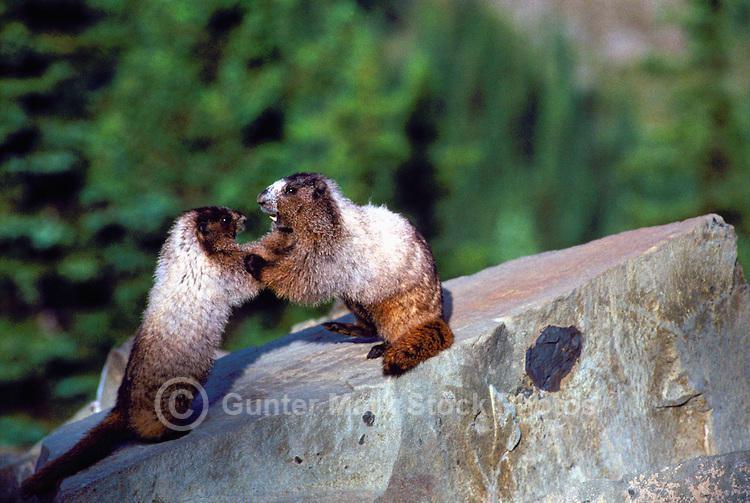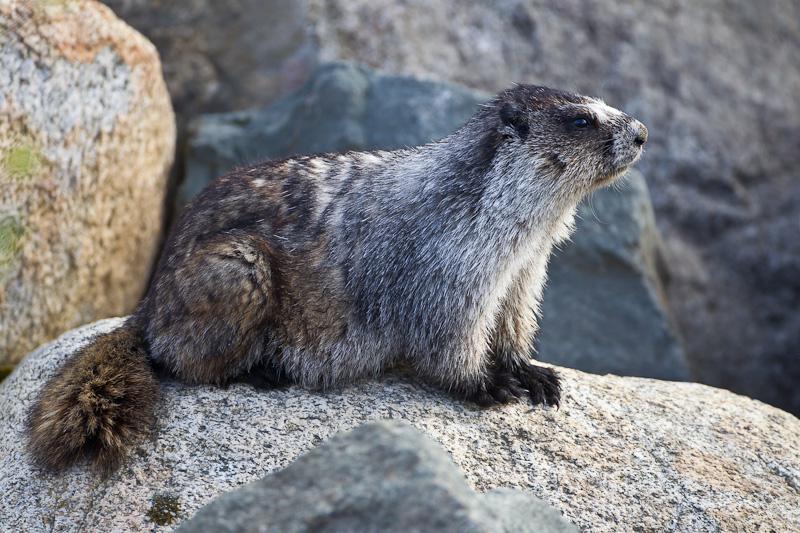The first image is the image on the left, the second image is the image on the right. For the images displayed, is the sentence "There is signal tan and brown animal sitting on a rock looking left." factually correct? Answer yes or no. No. The first image is the image on the left, the second image is the image on the right. For the images displayed, is the sentence "There are only two animals, and they are facing opposite directions." factually correct? Answer yes or no. No. The first image is the image on the left, the second image is the image on the right. Considering the images on both sides, is "Right image shows a rightward-facing marmot perched on a rock with its tail visible." valid? Answer yes or no. Yes. The first image is the image on the left, the second image is the image on the right. For the images displayed, is the sentence "At least one of the animals is standing up on its hind legs." factually correct? Answer yes or no. Yes. 